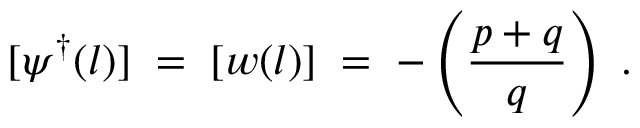Convert formula to latex. <formula><loc_0><loc_0><loc_500><loc_500>[ \psi ^ { \dagger } ( l ) ] \, = \, [ w ( l ) ] \, = \, - \left ( \frac { p + q } { q } \right ) \, .</formula> 